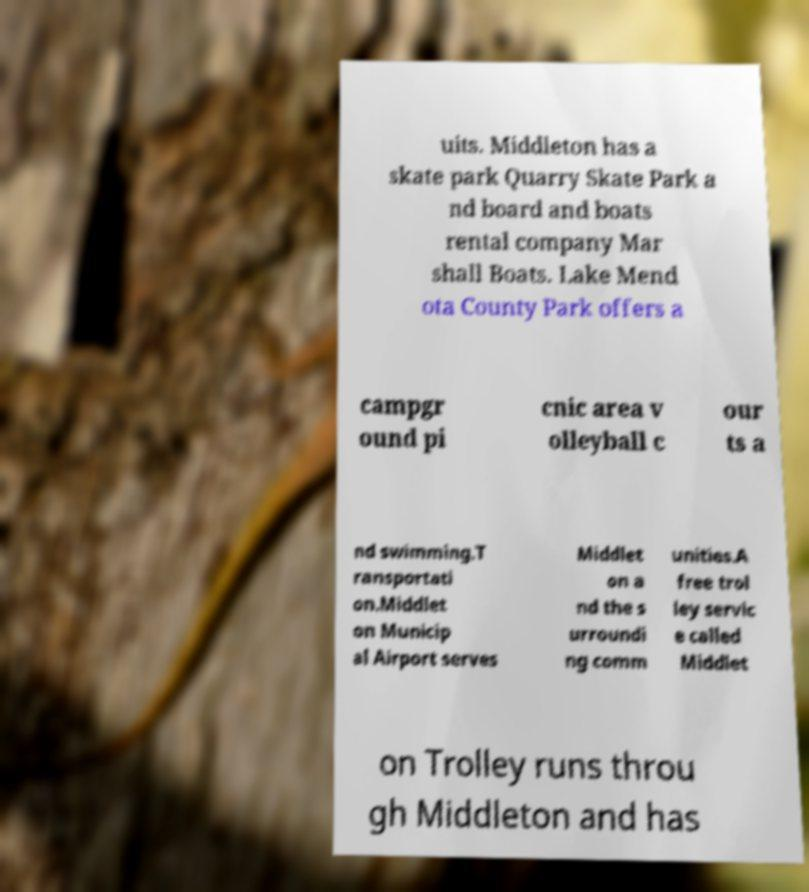Can you read and provide the text displayed in the image?This photo seems to have some interesting text. Can you extract and type it out for me? uits. Middleton has a skate park Quarry Skate Park a nd board and boats rental company Mar shall Boats. Lake Mend ota County Park offers a campgr ound pi cnic area v olleyball c our ts a nd swimming.T ransportati on.Middlet on Municip al Airport serves Middlet on a nd the s urroundi ng comm unities.A free trol ley servic e called Middlet on Trolley runs throu gh Middleton and has 